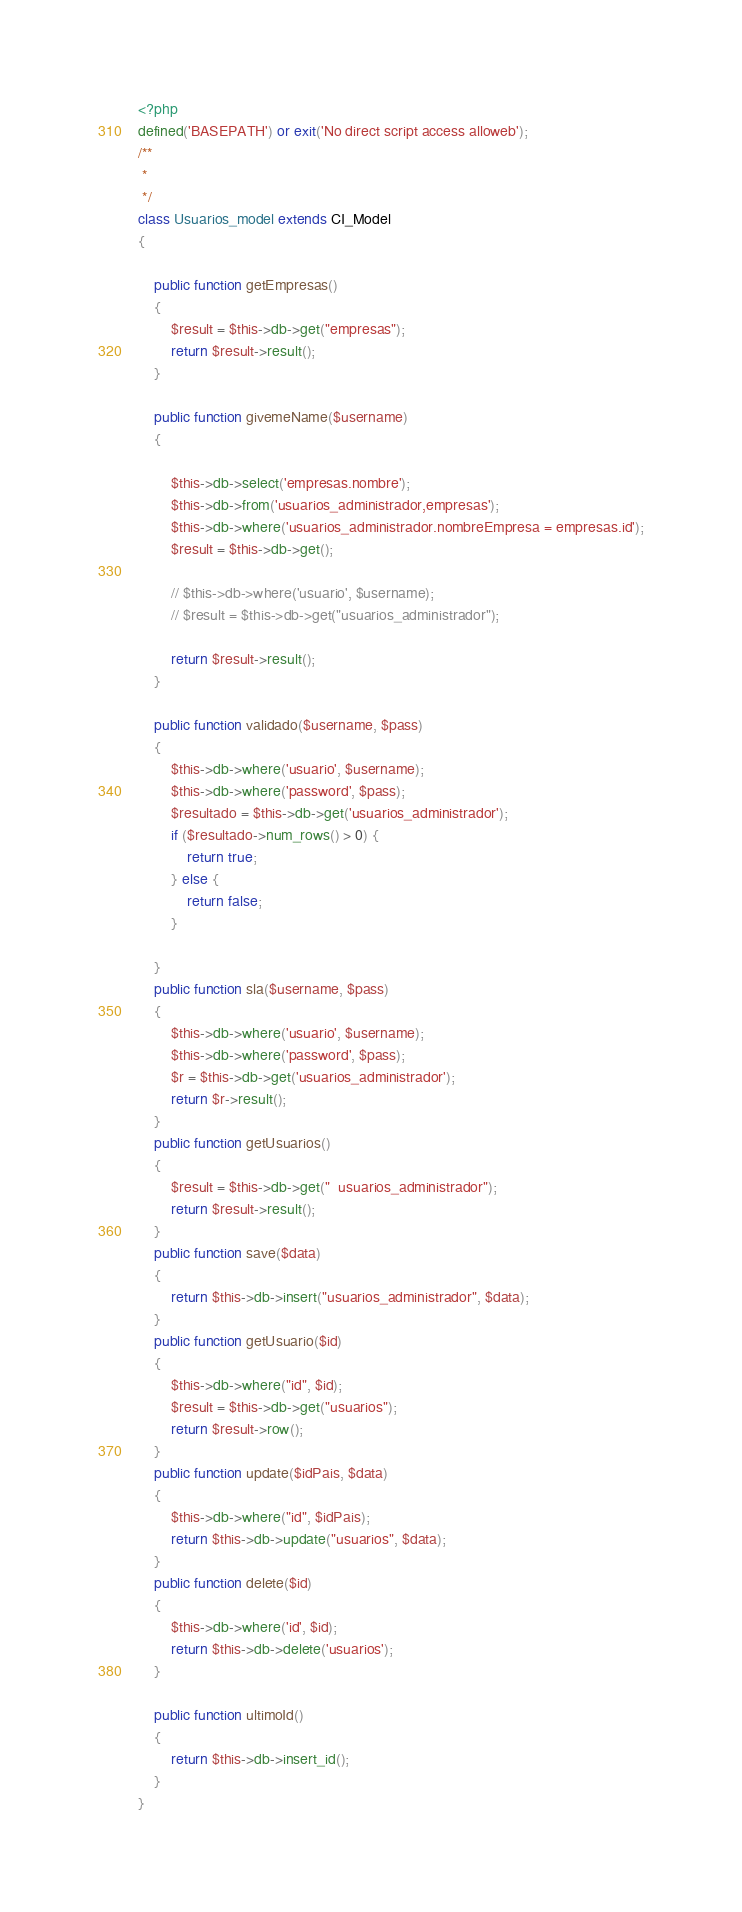<code> <loc_0><loc_0><loc_500><loc_500><_PHP_><?php
defined('BASEPATH') or exit('No direct script access alloweb');
/**
 *
 */
class Usuarios_model extends CI_Model
{

    public function getEmpresas()
    {
        $result = $this->db->get("empresas");
        return $result->result();
    }

    public function givemeName($username)
    {

        $this->db->select('empresas.nombre');
        $this->db->from('usuarios_administrador,empresas');
        $this->db->where('usuarios_administrador.nombreEmpresa = empresas.id');
        $result = $this->db->get();

        // $this->db->where('usuario', $username);
        // $result = $this->db->get("usuarios_administrador");

        return $result->result();
    }

    public function validado($username, $pass)
    {
        $this->db->where('usuario', $username);
        $this->db->where('password', $pass);
        $resultado = $this->db->get('usuarios_administrador');
        if ($resultado->num_rows() > 0) {
            return true;
        } else {
            return false;
        }

    }
    public function sla($username, $pass)
    {
        $this->db->where('usuario', $username);
        $this->db->where('password', $pass);
        $r = $this->db->get('usuarios_administrador');
        return $r->result();
    }
    public function getUsuarios()
    {
        $result = $this->db->get("  usuarios_administrador");
        return $result->result();
    }
    public function save($data)
    {
        return $this->db->insert("usuarios_administrador", $data);
    }
    public function getUsuario($id)
    {
        $this->db->where("id", $id);
        $result = $this->db->get("usuarios");
        return $result->row();
    }
    public function update($idPais, $data)
    {
        $this->db->where("id", $idPais);
        return $this->db->update("usuarios", $data);
    }
    public function delete($id)
    {
        $this->db->where('id', $id);
        return $this->db->delete('usuarios');
    }

    public function ultimoId()
    {
        return $this->db->insert_id();
    }
}
</code> 